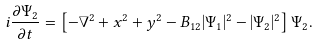Convert formula to latex. <formula><loc_0><loc_0><loc_500><loc_500>i \frac { \partial \Psi _ { 2 } } { \partial t } = \left [ - \nabla ^ { 2 } + x ^ { 2 } + y ^ { 2 } - B _ { 1 2 } | \Psi _ { 1 } | ^ { 2 } - | \Psi _ { 2 } | ^ { 2 } \right ] \Psi _ { 2 } .</formula> 